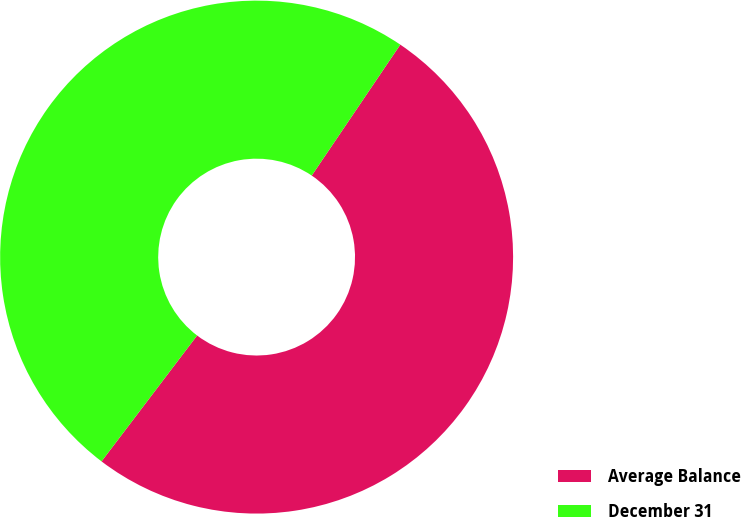Convert chart to OTSL. <chart><loc_0><loc_0><loc_500><loc_500><pie_chart><fcel>Average Balance<fcel>December 31<nl><fcel>50.87%<fcel>49.13%<nl></chart> 